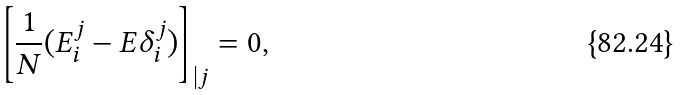<formula> <loc_0><loc_0><loc_500><loc_500>\left [ \frac { 1 } { N } ( E _ { i } ^ { j } - E \delta ^ { j } _ { i } ) \right ] _ { | j } = 0 ,</formula> 